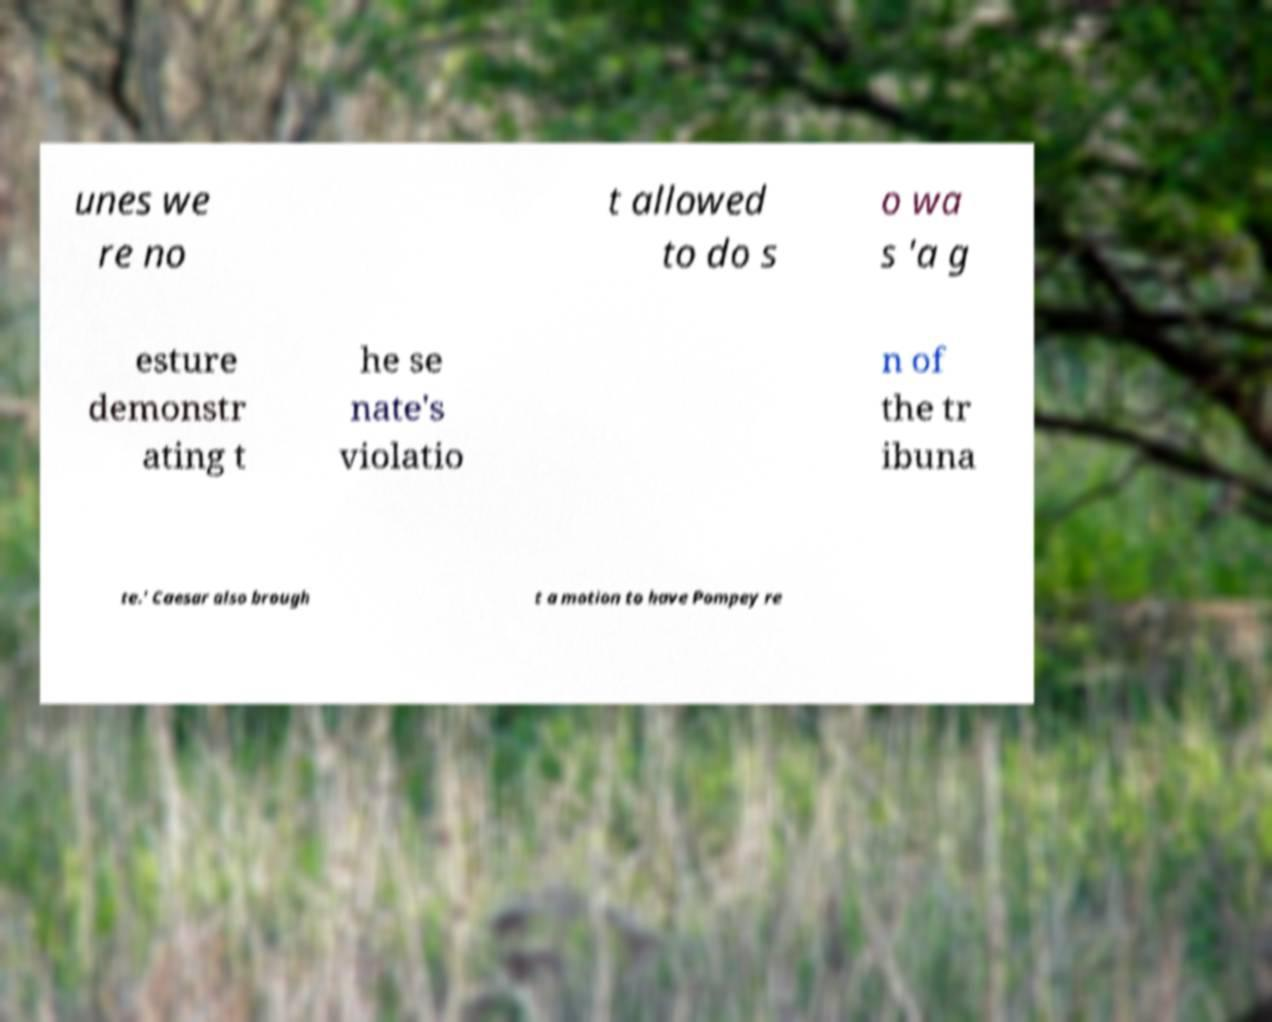Can you read and provide the text displayed in the image?This photo seems to have some interesting text. Can you extract and type it out for me? unes we re no t allowed to do s o wa s 'a g esture demonstr ating t he se nate's violatio n of the tr ibuna te.' Caesar also brough t a motion to have Pompey re 